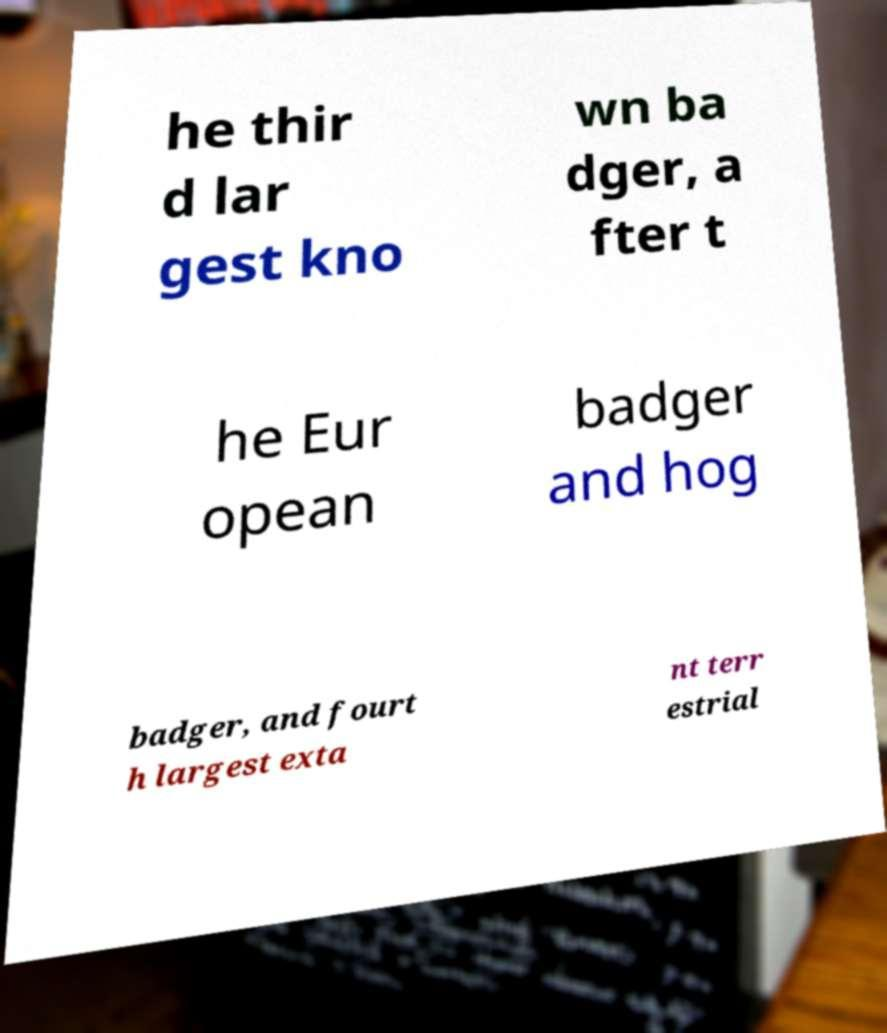What messages or text are displayed in this image? I need them in a readable, typed format. he thir d lar gest kno wn ba dger, a fter t he Eur opean badger and hog badger, and fourt h largest exta nt terr estrial 